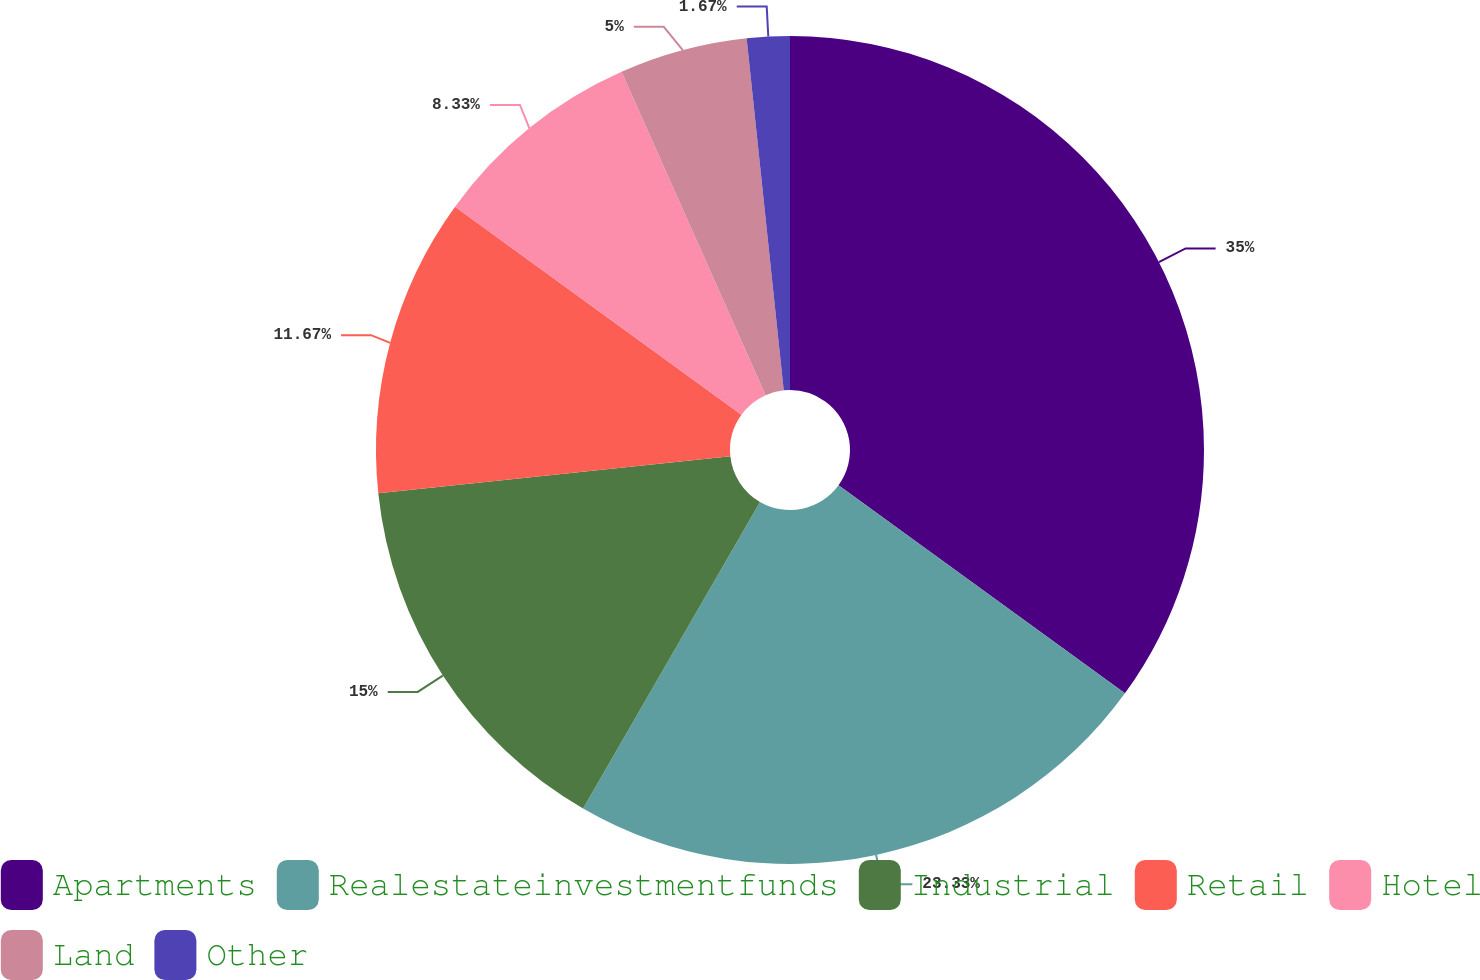Convert chart to OTSL. <chart><loc_0><loc_0><loc_500><loc_500><pie_chart><fcel>Apartments<fcel>Realestateinvestmentfunds<fcel>Industrial<fcel>Retail<fcel>Hotel<fcel>Land<fcel>Other<nl><fcel>35.0%<fcel>23.33%<fcel>15.0%<fcel>11.67%<fcel>8.33%<fcel>5.0%<fcel>1.67%<nl></chart> 